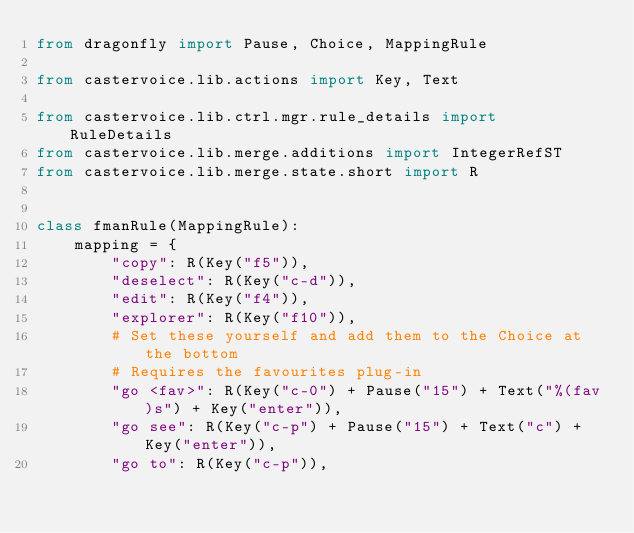<code> <loc_0><loc_0><loc_500><loc_500><_Python_>from dragonfly import Pause, Choice, MappingRule

from castervoice.lib.actions import Key, Text

from castervoice.lib.ctrl.mgr.rule_details import RuleDetails
from castervoice.lib.merge.additions import IntegerRefST
from castervoice.lib.merge.state.short import R


class fmanRule(MappingRule):
    mapping = {
        "copy": R(Key("f5")),
        "deselect": R(Key("c-d")),
        "edit": R(Key("f4")),
        "explorer": R(Key("f10")),
        # Set these yourself and add them to the Choice at the bottom
        # Requires the favourites plug-in
        "go <fav>": R(Key("c-0") + Pause("15") + Text("%(fav)s") + Key("enter")),
        "go see": R(Key("c-p") + Pause("15") + Text("c") + Key("enter")),
        "go to": R(Key("c-p")),</code> 